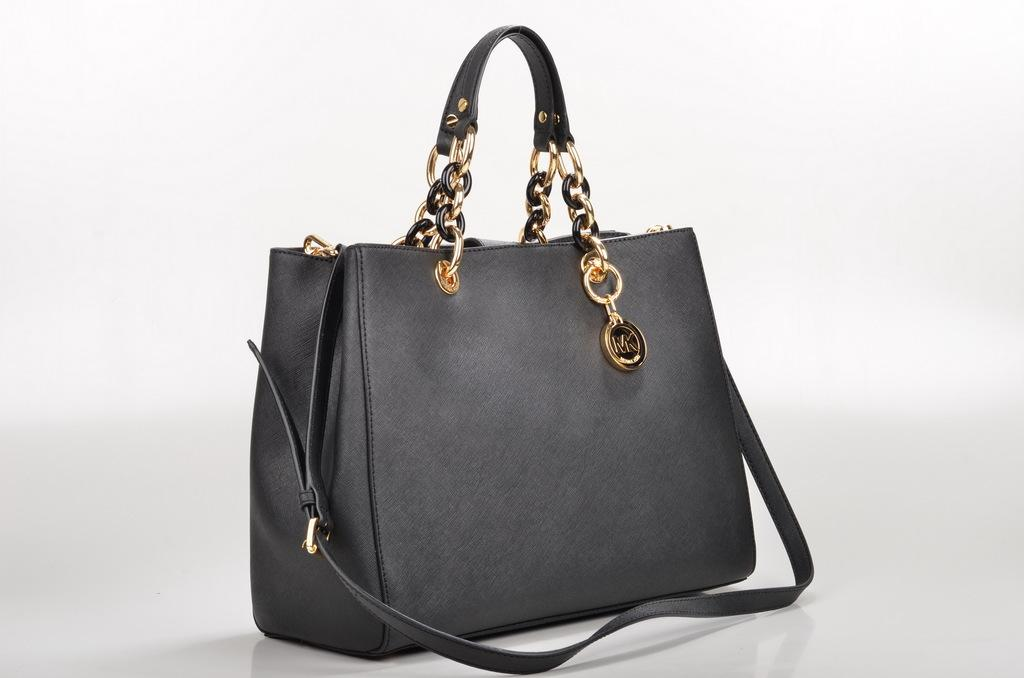What color is the handbag in the image? The handbag in the image is black colored. Where is the handbag located in the image? The handbag is placed on a table. What is the color of the background in the image? The background of the image is white. Can you see any icicles forming on the handbag in the image? There are no icicles present in the image, as it is indoors and the background is white. 